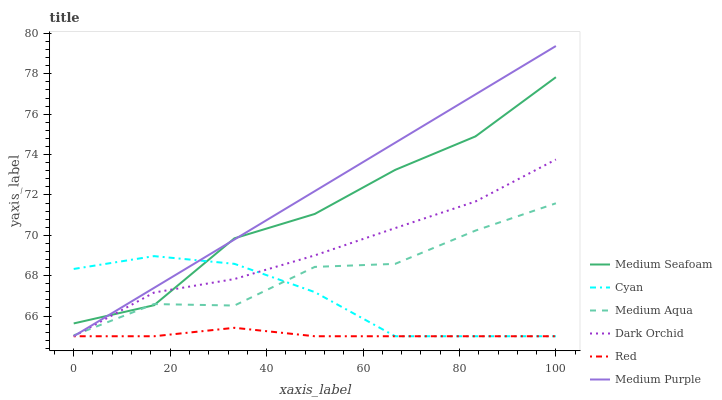Does Red have the minimum area under the curve?
Answer yes or no. Yes. Does Medium Purple have the maximum area under the curve?
Answer yes or no. Yes. Does Medium Aqua have the minimum area under the curve?
Answer yes or no. No. Does Medium Aqua have the maximum area under the curve?
Answer yes or no. No. Is Medium Purple the smoothest?
Answer yes or no. Yes. Is Medium Seafoam the roughest?
Answer yes or no. Yes. Is Medium Aqua the smoothest?
Answer yes or no. No. Is Medium Aqua the roughest?
Answer yes or no. No. Does Medium Aqua have the lowest value?
Answer yes or no. No. Does Medium Aqua have the highest value?
Answer yes or no. No. Is Red less than Medium Aqua?
Answer yes or no. Yes. Is Medium Aqua greater than Red?
Answer yes or no. Yes. Does Red intersect Medium Aqua?
Answer yes or no. No. 